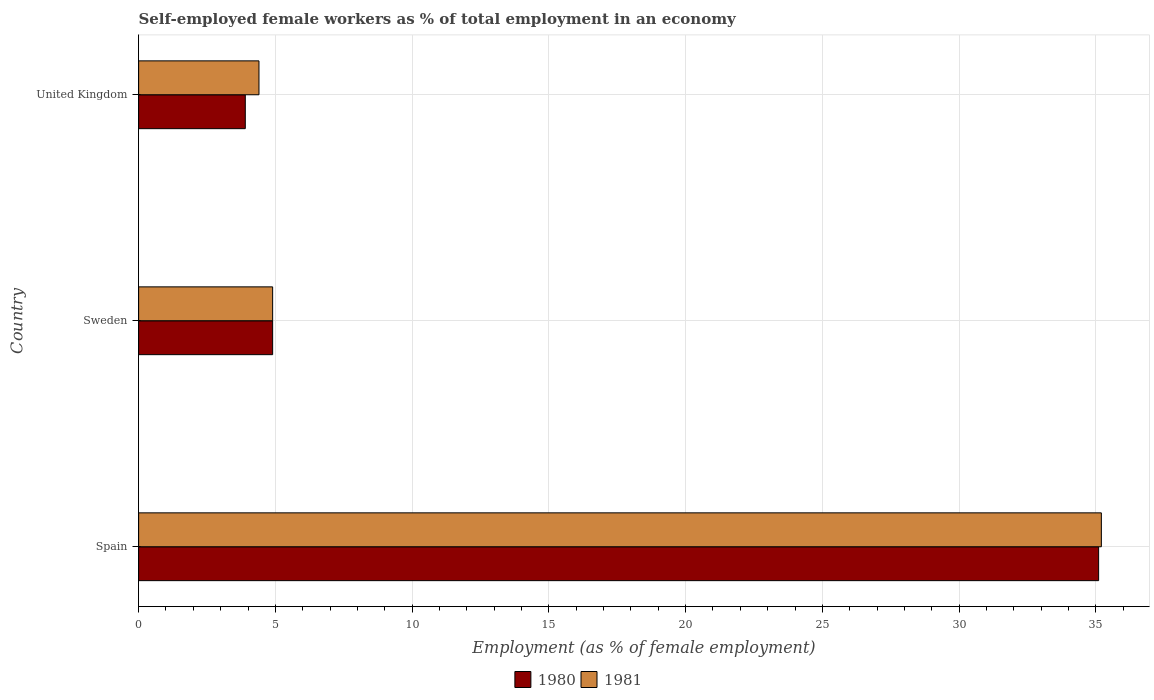How many groups of bars are there?
Your answer should be very brief. 3. Are the number of bars per tick equal to the number of legend labels?
Offer a very short reply. Yes. How many bars are there on the 1st tick from the top?
Ensure brevity in your answer.  2. What is the label of the 2nd group of bars from the top?
Your response must be concise. Sweden. In how many cases, is the number of bars for a given country not equal to the number of legend labels?
Your answer should be very brief. 0. What is the percentage of self-employed female workers in 1981 in Sweden?
Provide a succinct answer. 4.9. Across all countries, what is the maximum percentage of self-employed female workers in 1980?
Provide a short and direct response. 35.1. Across all countries, what is the minimum percentage of self-employed female workers in 1981?
Make the answer very short. 4.4. In which country was the percentage of self-employed female workers in 1981 minimum?
Provide a short and direct response. United Kingdom. What is the total percentage of self-employed female workers in 1980 in the graph?
Your answer should be compact. 43.9. What is the difference between the percentage of self-employed female workers in 1981 in Spain and the percentage of self-employed female workers in 1980 in Sweden?
Offer a terse response. 30.3. What is the average percentage of self-employed female workers in 1980 per country?
Give a very brief answer. 14.63. What is the difference between the percentage of self-employed female workers in 1981 and percentage of self-employed female workers in 1980 in Sweden?
Provide a short and direct response. 0. What is the ratio of the percentage of self-employed female workers in 1981 in Spain to that in Sweden?
Ensure brevity in your answer.  7.18. Is the difference between the percentage of self-employed female workers in 1981 in Sweden and United Kingdom greater than the difference between the percentage of self-employed female workers in 1980 in Sweden and United Kingdom?
Offer a very short reply. No. What is the difference between the highest and the second highest percentage of self-employed female workers in 1981?
Your answer should be very brief. 30.3. What is the difference between the highest and the lowest percentage of self-employed female workers in 1980?
Your answer should be very brief. 31.2. Is the sum of the percentage of self-employed female workers in 1980 in Spain and Sweden greater than the maximum percentage of self-employed female workers in 1981 across all countries?
Provide a short and direct response. Yes. What does the 1st bar from the top in Spain represents?
Offer a terse response. 1981. What does the 1st bar from the bottom in United Kingdom represents?
Your response must be concise. 1980. What is the difference between two consecutive major ticks on the X-axis?
Provide a succinct answer. 5. Are the values on the major ticks of X-axis written in scientific E-notation?
Your response must be concise. No. Does the graph contain any zero values?
Offer a very short reply. No. Where does the legend appear in the graph?
Your answer should be compact. Bottom center. What is the title of the graph?
Keep it short and to the point. Self-employed female workers as % of total employment in an economy. Does "1989" appear as one of the legend labels in the graph?
Provide a short and direct response. No. What is the label or title of the X-axis?
Your answer should be compact. Employment (as % of female employment). What is the Employment (as % of female employment) of 1980 in Spain?
Your response must be concise. 35.1. What is the Employment (as % of female employment) in 1981 in Spain?
Keep it short and to the point. 35.2. What is the Employment (as % of female employment) of 1980 in Sweden?
Your answer should be very brief. 4.9. What is the Employment (as % of female employment) of 1981 in Sweden?
Your answer should be very brief. 4.9. What is the Employment (as % of female employment) of 1980 in United Kingdom?
Keep it short and to the point. 3.9. What is the Employment (as % of female employment) in 1981 in United Kingdom?
Make the answer very short. 4.4. Across all countries, what is the maximum Employment (as % of female employment) of 1980?
Give a very brief answer. 35.1. Across all countries, what is the maximum Employment (as % of female employment) in 1981?
Your response must be concise. 35.2. Across all countries, what is the minimum Employment (as % of female employment) of 1980?
Keep it short and to the point. 3.9. Across all countries, what is the minimum Employment (as % of female employment) of 1981?
Offer a very short reply. 4.4. What is the total Employment (as % of female employment) in 1980 in the graph?
Provide a short and direct response. 43.9. What is the total Employment (as % of female employment) of 1981 in the graph?
Ensure brevity in your answer.  44.5. What is the difference between the Employment (as % of female employment) of 1980 in Spain and that in Sweden?
Make the answer very short. 30.2. What is the difference between the Employment (as % of female employment) of 1981 in Spain and that in Sweden?
Your answer should be very brief. 30.3. What is the difference between the Employment (as % of female employment) in 1980 in Spain and that in United Kingdom?
Your answer should be compact. 31.2. What is the difference between the Employment (as % of female employment) of 1981 in Spain and that in United Kingdom?
Provide a short and direct response. 30.8. What is the difference between the Employment (as % of female employment) in 1980 in Spain and the Employment (as % of female employment) in 1981 in Sweden?
Make the answer very short. 30.2. What is the difference between the Employment (as % of female employment) of 1980 in Spain and the Employment (as % of female employment) of 1981 in United Kingdom?
Give a very brief answer. 30.7. What is the difference between the Employment (as % of female employment) of 1980 in Sweden and the Employment (as % of female employment) of 1981 in United Kingdom?
Provide a short and direct response. 0.5. What is the average Employment (as % of female employment) of 1980 per country?
Your response must be concise. 14.63. What is the average Employment (as % of female employment) in 1981 per country?
Your answer should be very brief. 14.83. What is the difference between the Employment (as % of female employment) in 1980 and Employment (as % of female employment) in 1981 in Spain?
Your answer should be very brief. -0.1. What is the difference between the Employment (as % of female employment) in 1980 and Employment (as % of female employment) in 1981 in Sweden?
Give a very brief answer. 0. What is the ratio of the Employment (as % of female employment) of 1980 in Spain to that in Sweden?
Provide a short and direct response. 7.16. What is the ratio of the Employment (as % of female employment) in 1981 in Spain to that in Sweden?
Ensure brevity in your answer.  7.18. What is the ratio of the Employment (as % of female employment) in 1981 in Spain to that in United Kingdom?
Provide a succinct answer. 8. What is the ratio of the Employment (as % of female employment) of 1980 in Sweden to that in United Kingdom?
Your answer should be compact. 1.26. What is the ratio of the Employment (as % of female employment) in 1981 in Sweden to that in United Kingdom?
Give a very brief answer. 1.11. What is the difference between the highest and the second highest Employment (as % of female employment) of 1980?
Keep it short and to the point. 30.2. What is the difference between the highest and the second highest Employment (as % of female employment) of 1981?
Give a very brief answer. 30.3. What is the difference between the highest and the lowest Employment (as % of female employment) of 1980?
Make the answer very short. 31.2. What is the difference between the highest and the lowest Employment (as % of female employment) of 1981?
Keep it short and to the point. 30.8. 